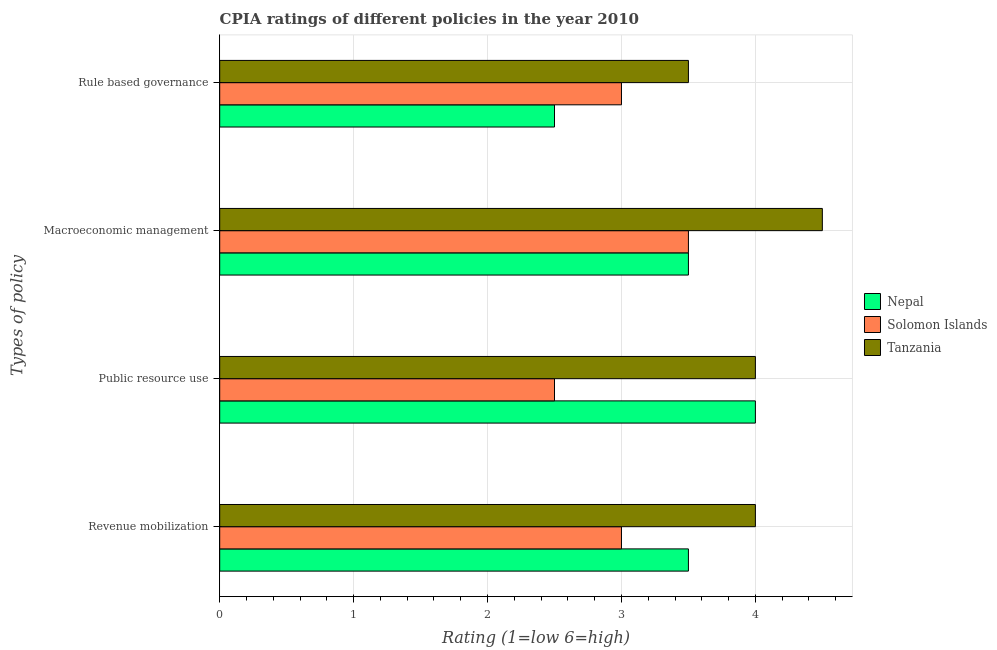How many different coloured bars are there?
Keep it short and to the point. 3. How many groups of bars are there?
Provide a succinct answer. 4. Are the number of bars per tick equal to the number of legend labels?
Offer a terse response. Yes. How many bars are there on the 4th tick from the top?
Offer a terse response. 3. How many bars are there on the 1st tick from the bottom?
Offer a very short reply. 3. What is the label of the 1st group of bars from the top?
Keep it short and to the point. Rule based governance. Across all countries, what is the maximum cpia rating of revenue mobilization?
Ensure brevity in your answer.  4. Across all countries, what is the minimum cpia rating of public resource use?
Ensure brevity in your answer.  2.5. In which country was the cpia rating of rule based governance maximum?
Offer a very short reply. Tanzania. In which country was the cpia rating of public resource use minimum?
Keep it short and to the point. Solomon Islands. What is the total cpia rating of macroeconomic management in the graph?
Your response must be concise. 11.5. What is the difference between the cpia rating of rule based governance in Tanzania and that in Nepal?
Ensure brevity in your answer.  1. What is the difference between the cpia rating of rule based governance and cpia rating of public resource use in Solomon Islands?
Your answer should be very brief. 0.5. What is the ratio of the cpia rating of macroeconomic management in Nepal to that in Tanzania?
Offer a very short reply. 0.78. Is the difference between the cpia rating of rule based governance in Solomon Islands and Nepal greater than the difference between the cpia rating of revenue mobilization in Solomon Islands and Nepal?
Offer a very short reply. Yes. What is the difference between the highest and the second highest cpia rating of macroeconomic management?
Your answer should be very brief. 1. What is the difference between the highest and the lowest cpia rating of public resource use?
Your answer should be very brief. 1.5. Is the sum of the cpia rating of rule based governance in Nepal and Solomon Islands greater than the maximum cpia rating of macroeconomic management across all countries?
Your answer should be compact. Yes. Is it the case that in every country, the sum of the cpia rating of macroeconomic management and cpia rating of rule based governance is greater than the sum of cpia rating of revenue mobilization and cpia rating of public resource use?
Keep it short and to the point. No. What does the 3rd bar from the top in Public resource use represents?
Ensure brevity in your answer.  Nepal. What does the 3rd bar from the bottom in Macroeconomic management represents?
Keep it short and to the point. Tanzania. Is it the case that in every country, the sum of the cpia rating of revenue mobilization and cpia rating of public resource use is greater than the cpia rating of macroeconomic management?
Make the answer very short. Yes. How many bars are there?
Offer a very short reply. 12. Are all the bars in the graph horizontal?
Provide a short and direct response. Yes. How many countries are there in the graph?
Provide a short and direct response. 3. How many legend labels are there?
Offer a terse response. 3. How are the legend labels stacked?
Offer a very short reply. Vertical. What is the title of the graph?
Give a very brief answer. CPIA ratings of different policies in the year 2010. Does "Luxembourg" appear as one of the legend labels in the graph?
Give a very brief answer. No. What is the label or title of the Y-axis?
Your answer should be compact. Types of policy. What is the Rating (1=low 6=high) in Tanzania in Revenue mobilization?
Make the answer very short. 4. What is the Rating (1=low 6=high) of Nepal in Public resource use?
Provide a short and direct response. 4. What is the Rating (1=low 6=high) of Nepal in Macroeconomic management?
Provide a short and direct response. 3.5. What is the Rating (1=low 6=high) of Nepal in Rule based governance?
Your response must be concise. 2.5. What is the Rating (1=low 6=high) in Solomon Islands in Rule based governance?
Offer a very short reply. 3. What is the Rating (1=low 6=high) in Tanzania in Rule based governance?
Keep it short and to the point. 3.5. Across all Types of policy, what is the maximum Rating (1=low 6=high) of Nepal?
Your answer should be very brief. 4. Across all Types of policy, what is the maximum Rating (1=low 6=high) in Solomon Islands?
Provide a short and direct response. 3.5. Across all Types of policy, what is the minimum Rating (1=low 6=high) in Tanzania?
Give a very brief answer. 3.5. What is the total Rating (1=low 6=high) in Solomon Islands in the graph?
Offer a very short reply. 12. What is the total Rating (1=low 6=high) in Tanzania in the graph?
Your answer should be very brief. 16. What is the difference between the Rating (1=low 6=high) of Nepal in Revenue mobilization and that in Public resource use?
Your answer should be compact. -0.5. What is the difference between the Rating (1=low 6=high) of Tanzania in Revenue mobilization and that in Public resource use?
Your answer should be very brief. 0. What is the difference between the Rating (1=low 6=high) in Nepal in Revenue mobilization and that in Macroeconomic management?
Ensure brevity in your answer.  0. What is the difference between the Rating (1=low 6=high) of Solomon Islands in Revenue mobilization and that in Macroeconomic management?
Give a very brief answer. -0.5. What is the difference between the Rating (1=low 6=high) in Nepal in Public resource use and that in Macroeconomic management?
Offer a very short reply. 0.5. What is the difference between the Rating (1=low 6=high) in Tanzania in Public resource use and that in Macroeconomic management?
Give a very brief answer. -0.5. What is the difference between the Rating (1=low 6=high) in Nepal in Public resource use and that in Rule based governance?
Provide a short and direct response. 1.5. What is the difference between the Rating (1=low 6=high) in Solomon Islands in Public resource use and that in Rule based governance?
Give a very brief answer. -0.5. What is the difference between the Rating (1=low 6=high) of Nepal in Macroeconomic management and that in Rule based governance?
Offer a very short reply. 1. What is the difference between the Rating (1=low 6=high) of Solomon Islands in Macroeconomic management and that in Rule based governance?
Keep it short and to the point. 0.5. What is the difference between the Rating (1=low 6=high) in Tanzania in Macroeconomic management and that in Rule based governance?
Offer a very short reply. 1. What is the difference between the Rating (1=low 6=high) of Nepal in Revenue mobilization and the Rating (1=low 6=high) of Tanzania in Public resource use?
Offer a very short reply. -0.5. What is the difference between the Rating (1=low 6=high) of Solomon Islands in Revenue mobilization and the Rating (1=low 6=high) of Tanzania in Public resource use?
Ensure brevity in your answer.  -1. What is the difference between the Rating (1=low 6=high) in Nepal in Revenue mobilization and the Rating (1=low 6=high) in Tanzania in Macroeconomic management?
Provide a succinct answer. -1. What is the difference between the Rating (1=low 6=high) of Nepal in Revenue mobilization and the Rating (1=low 6=high) of Solomon Islands in Rule based governance?
Ensure brevity in your answer.  0.5. What is the difference between the Rating (1=low 6=high) in Nepal in Revenue mobilization and the Rating (1=low 6=high) in Tanzania in Rule based governance?
Your answer should be compact. 0. What is the difference between the Rating (1=low 6=high) in Solomon Islands in Public resource use and the Rating (1=low 6=high) in Tanzania in Macroeconomic management?
Provide a succinct answer. -2. What is the difference between the Rating (1=low 6=high) of Nepal in Public resource use and the Rating (1=low 6=high) of Solomon Islands in Rule based governance?
Ensure brevity in your answer.  1. What is the difference between the Rating (1=low 6=high) in Nepal in Public resource use and the Rating (1=low 6=high) in Tanzania in Rule based governance?
Give a very brief answer. 0.5. What is the difference between the Rating (1=low 6=high) of Solomon Islands in Macroeconomic management and the Rating (1=low 6=high) of Tanzania in Rule based governance?
Your response must be concise. 0. What is the average Rating (1=low 6=high) in Nepal per Types of policy?
Offer a very short reply. 3.38. What is the average Rating (1=low 6=high) of Tanzania per Types of policy?
Offer a very short reply. 4. What is the difference between the Rating (1=low 6=high) of Nepal and Rating (1=low 6=high) of Solomon Islands in Revenue mobilization?
Your answer should be very brief. 0.5. What is the difference between the Rating (1=low 6=high) of Nepal and Rating (1=low 6=high) of Tanzania in Revenue mobilization?
Offer a very short reply. -0.5. What is the difference between the Rating (1=low 6=high) of Nepal and Rating (1=low 6=high) of Solomon Islands in Public resource use?
Your response must be concise. 1.5. What is the difference between the Rating (1=low 6=high) of Nepal and Rating (1=low 6=high) of Solomon Islands in Rule based governance?
Provide a short and direct response. -0.5. What is the difference between the Rating (1=low 6=high) of Nepal and Rating (1=low 6=high) of Tanzania in Rule based governance?
Make the answer very short. -1. What is the difference between the Rating (1=low 6=high) in Solomon Islands and Rating (1=low 6=high) in Tanzania in Rule based governance?
Keep it short and to the point. -0.5. What is the ratio of the Rating (1=low 6=high) in Nepal in Revenue mobilization to that in Public resource use?
Give a very brief answer. 0.88. What is the ratio of the Rating (1=low 6=high) in Nepal in Revenue mobilization to that in Rule based governance?
Offer a terse response. 1.4. What is the ratio of the Rating (1=low 6=high) of Solomon Islands in Revenue mobilization to that in Rule based governance?
Your answer should be very brief. 1. What is the ratio of the Rating (1=low 6=high) of Nepal in Public resource use to that in Macroeconomic management?
Give a very brief answer. 1.14. What is the ratio of the Rating (1=low 6=high) in Solomon Islands in Public resource use to that in Macroeconomic management?
Give a very brief answer. 0.71. What is the ratio of the Rating (1=low 6=high) of Tanzania in Public resource use to that in Macroeconomic management?
Give a very brief answer. 0.89. What is the ratio of the Rating (1=low 6=high) in Nepal in Public resource use to that in Rule based governance?
Your response must be concise. 1.6. What is the ratio of the Rating (1=low 6=high) in Tanzania in Public resource use to that in Rule based governance?
Make the answer very short. 1.14. What is the ratio of the Rating (1=low 6=high) in Nepal in Macroeconomic management to that in Rule based governance?
Ensure brevity in your answer.  1.4. What is the ratio of the Rating (1=low 6=high) of Solomon Islands in Macroeconomic management to that in Rule based governance?
Keep it short and to the point. 1.17. What is the ratio of the Rating (1=low 6=high) of Tanzania in Macroeconomic management to that in Rule based governance?
Provide a succinct answer. 1.29. What is the difference between the highest and the second highest Rating (1=low 6=high) of Nepal?
Keep it short and to the point. 0.5. What is the difference between the highest and the second highest Rating (1=low 6=high) in Solomon Islands?
Provide a succinct answer. 0.5. What is the difference between the highest and the second highest Rating (1=low 6=high) of Tanzania?
Provide a succinct answer. 0.5. What is the difference between the highest and the lowest Rating (1=low 6=high) in Nepal?
Keep it short and to the point. 1.5. What is the difference between the highest and the lowest Rating (1=low 6=high) of Tanzania?
Provide a short and direct response. 1. 